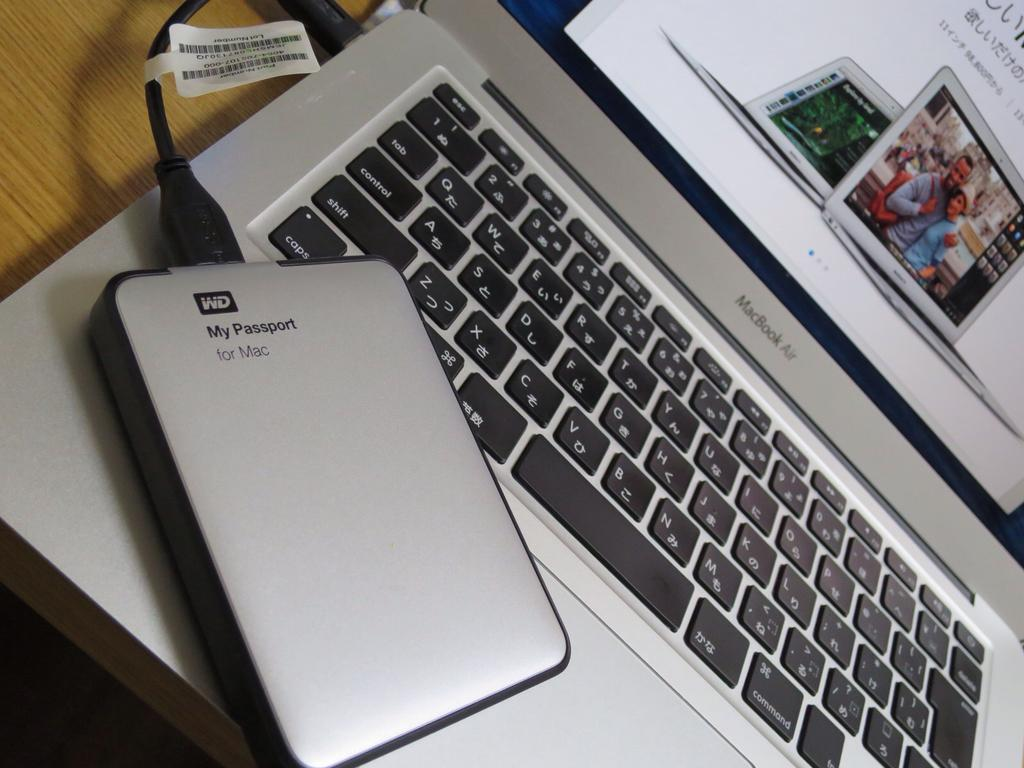<image>
Give a short and clear explanation of the subsequent image. A computer peripheral is made by WD and called My Passport. 